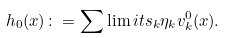Convert formula to latex. <formula><loc_0><loc_0><loc_500><loc_500>h _ { 0 } ( x ) \colon = \sum \lim i t s _ { k } \eta _ { k } v _ { k } ^ { 0 } ( x ) .</formula> 